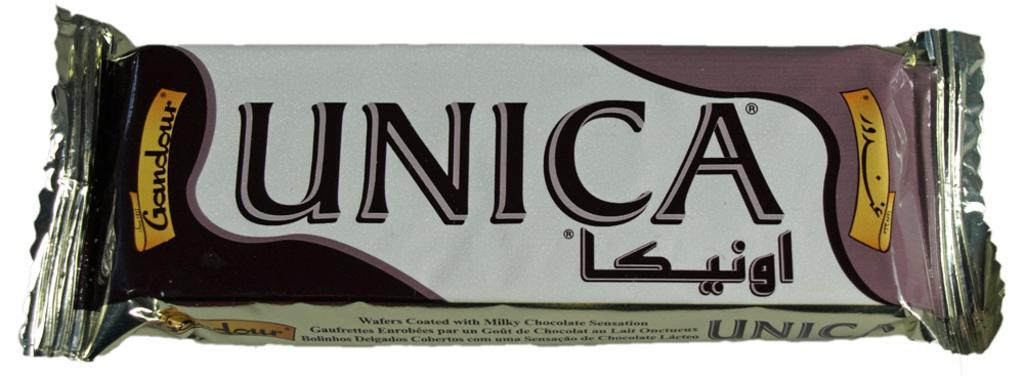What is the main subject of the image? There is a chocolate in the center of the image. What can be seen on the chocolate's packaging? There is text on the wrapper of the chocolate. What color is the background of the image? The background of the image is white in color. Where is the bottle placed in relation to the chocolate in the image? There is no bottle present in the image. What type of throne is depicted in the image? There is no throne present in the image. 